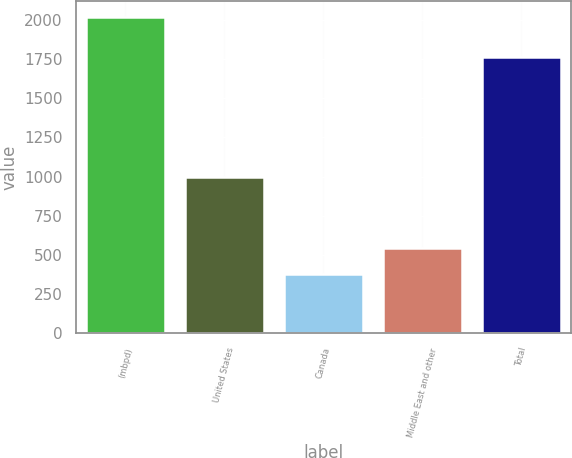Convert chart to OTSL. <chart><loc_0><loc_0><loc_500><loc_500><bar_chart><fcel>(mbpd)<fcel>United States<fcel>Canada<fcel>Middle East and other<fcel>Total<nl><fcel>2017<fcel>999<fcel>381<fcel>544.6<fcel>1765<nl></chart> 